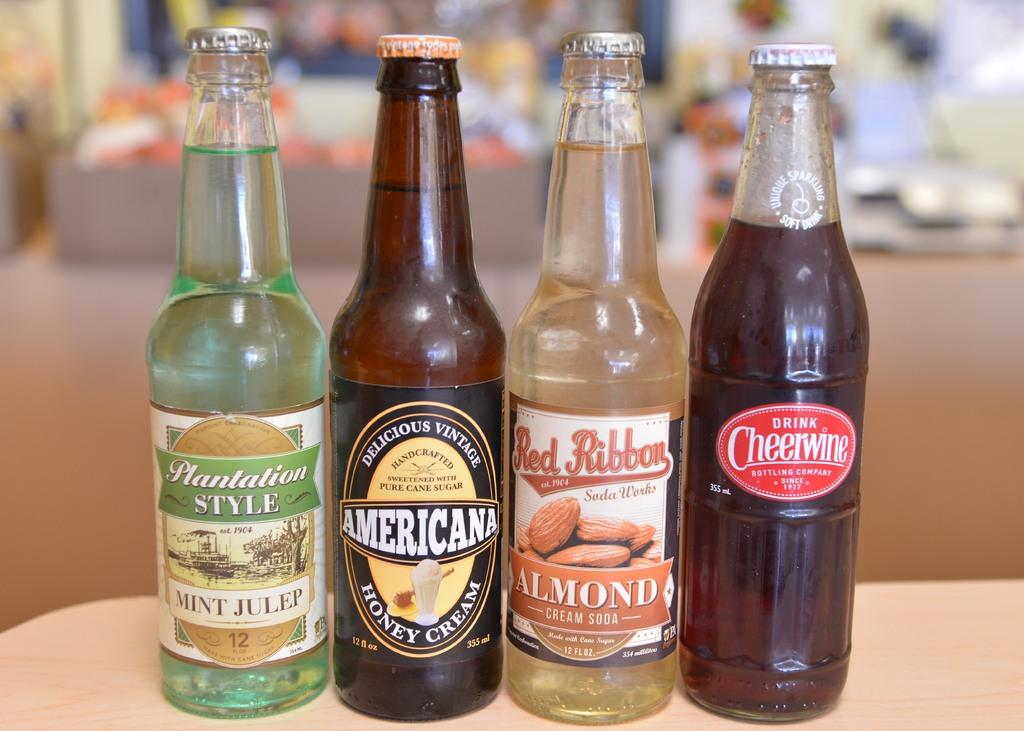<image>
Summarize the visual content of the image. A line of drink bottles one of which is by the brand American 